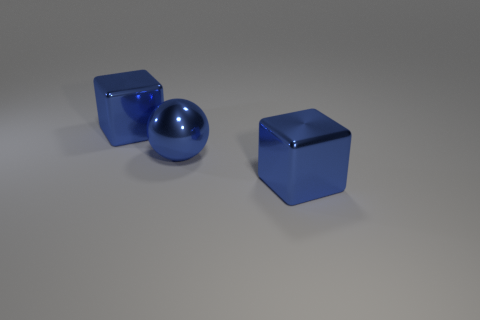Add 3 small red rubber spheres. How many objects exist? 6 Subtract 1 balls. How many balls are left? 0 Subtract all balls. Subtract all metal spheres. How many objects are left? 1 Add 2 metal spheres. How many metal spheres are left? 3 Add 1 large cubes. How many large cubes exist? 3 Subtract 0 brown cubes. How many objects are left? 3 Subtract all blocks. How many objects are left? 1 Subtract all red blocks. Subtract all gray cylinders. How many blocks are left? 2 